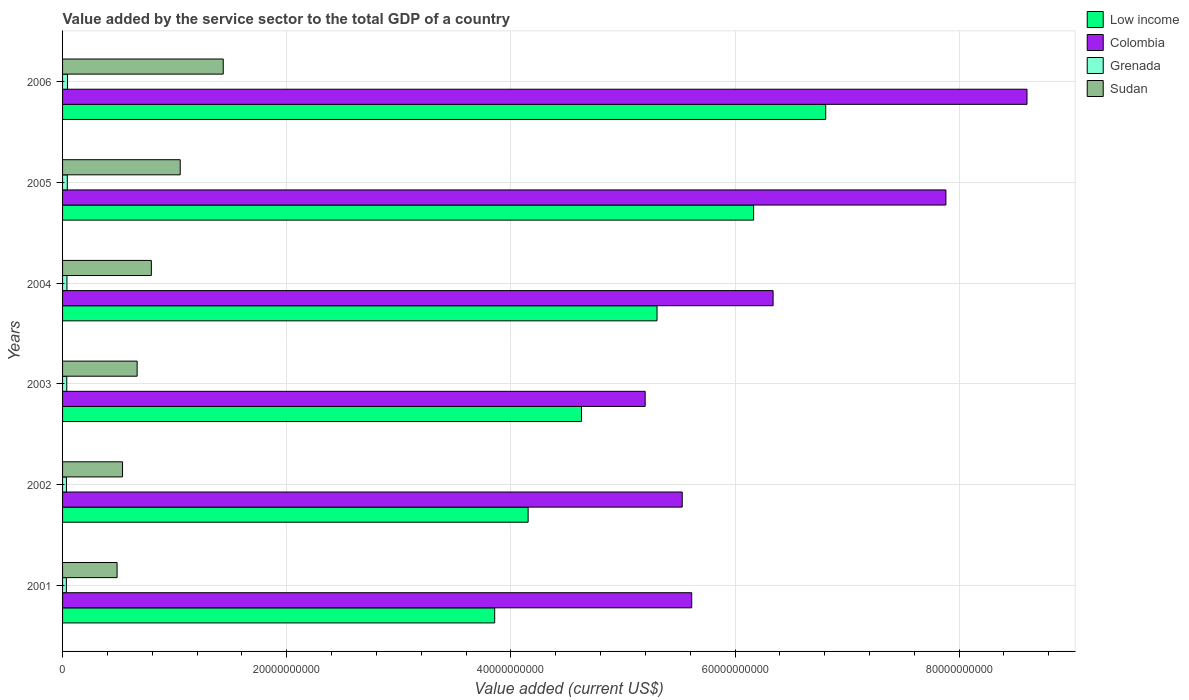Are the number of bars per tick equal to the number of legend labels?
Provide a succinct answer. Yes. How many bars are there on the 3rd tick from the top?
Provide a short and direct response. 4. How many bars are there on the 3rd tick from the bottom?
Offer a terse response. 4. What is the value added by the service sector to the total GDP in Colombia in 2004?
Provide a succinct answer. 6.34e+1. Across all years, what is the maximum value added by the service sector to the total GDP in Low income?
Your answer should be very brief. 6.81e+1. Across all years, what is the minimum value added by the service sector to the total GDP in Low income?
Ensure brevity in your answer.  3.86e+1. What is the total value added by the service sector to the total GDP in Sudan in the graph?
Ensure brevity in your answer.  4.96e+1. What is the difference between the value added by the service sector to the total GDP in Sudan in 2002 and that in 2005?
Your response must be concise. -5.15e+09. What is the difference between the value added by the service sector to the total GDP in Grenada in 2001 and the value added by the service sector to the total GDP in Low income in 2003?
Your response must be concise. -4.60e+1. What is the average value added by the service sector to the total GDP in Low income per year?
Keep it short and to the point. 5.15e+1. In the year 2004, what is the difference between the value added by the service sector to the total GDP in Grenada and value added by the service sector to the total GDP in Colombia?
Provide a short and direct response. -6.30e+1. In how many years, is the value added by the service sector to the total GDP in Low income greater than 44000000000 US$?
Offer a terse response. 4. What is the ratio of the value added by the service sector to the total GDP in Low income in 2002 to that in 2003?
Ensure brevity in your answer.  0.9. Is the difference between the value added by the service sector to the total GDP in Grenada in 2001 and 2002 greater than the difference between the value added by the service sector to the total GDP in Colombia in 2001 and 2002?
Provide a succinct answer. No. What is the difference between the highest and the second highest value added by the service sector to the total GDP in Grenada?
Ensure brevity in your answer.  1.71e+07. What is the difference between the highest and the lowest value added by the service sector to the total GDP in Sudan?
Your response must be concise. 9.47e+09. Is the sum of the value added by the service sector to the total GDP in Low income in 2003 and 2004 greater than the maximum value added by the service sector to the total GDP in Sudan across all years?
Ensure brevity in your answer.  Yes. What does the 1st bar from the top in 2003 represents?
Your answer should be very brief. Sudan. What does the 2nd bar from the bottom in 2004 represents?
Make the answer very short. Colombia. Is it the case that in every year, the sum of the value added by the service sector to the total GDP in Sudan and value added by the service sector to the total GDP in Low income is greater than the value added by the service sector to the total GDP in Grenada?
Give a very brief answer. Yes. Are the values on the major ticks of X-axis written in scientific E-notation?
Provide a short and direct response. No. Does the graph contain any zero values?
Your answer should be compact. No. Does the graph contain grids?
Ensure brevity in your answer.  Yes. Where does the legend appear in the graph?
Your response must be concise. Top right. How are the legend labels stacked?
Offer a very short reply. Vertical. What is the title of the graph?
Give a very brief answer. Value added by the service sector to the total GDP of a country. Does "Bolivia" appear as one of the legend labels in the graph?
Keep it short and to the point. No. What is the label or title of the X-axis?
Keep it short and to the point. Value added (current US$). What is the label or title of the Y-axis?
Give a very brief answer. Years. What is the Value added (current US$) in Low income in 2001?
Keep it short and to the point. 3.86e+1. What is the Value added (current US$) in Colombia in 2001?
Offer a terse response. 5.61e+1. What is the Value added (current US$) in Grenada in 2001?
Make the answer very short. 3.39e+08. What is the Value added (current US$) in Sudan in 2001?
Ensure brevity in your answer.  4.87e+09. What is the Value added (current US$) in Low income in 2002?
Give a very brief answer. 4.15e+1. What is the Value added (current US$) in Colombia in 2002?
Keep it short and to the point. 5.53e+1. What is the Value added (current US$) in Grenada in 2002?
Ensure brevity in your answer.  3.46e+08. What is the Value added (current US$) in Sudan in 2002?
Offer a terse response. 5.35e+09. What is the Value added (current US$) of Low income in 2003?
Keep it short and to the point. 4.63e+1. What is the Value added (current US$) of Colombia in 2003?
Offer a very short reply. 5.20e+1. What is the Value added (current US$) in Grenada in 2003?
Your response must be concise. 3.75e+08. What is the Value added (current US$) of Sudan in 2003?
Provide a short and direct response. 6.65e+09. What is the Value added (current US$) in Low income in 2004?
Offer a very short reply. 5.30e+1. What is the Value added (current US$) of Colombia in 2004?
Your response must be concise. 6.34e+1. What is the Value added (current US$) of Grenada in 2004?
Keep it short and to the point. 3.91e+08. What is the Value added (current US$) in Sudan in 2004?
Make the answer very short. 7.92e+09. What is the Value added (current US$) of Low income in 2005?
Provide a short and direct response. 6.17e+1. What is the Value added (current US$) of Colombia in 2005?
Offer a very short reply. 7.88e+1. What is the Value added (current US$) of Grenada in 2005?
Offer a very short reply. 4.21e+08. What is the Value added (current US$) of Sudan in 2005?
Provide a short and direct response. 1.05e+1. What is the Value added (current US$) of Low income in 2006?
Make the answer very short. 6.81e+1. What is the Value added (current US$) of Colombia in 2006?
Give a very brief answer. 8.61e+1. What is the Value added (current US$) of Grenada in 2006?
Ensure brevity in your answer.  4.38e+08. What is the Value added (current US$) of Sudan in 2006?
Provide a succinct answer. 1.43e+1. Across all years, what is the maximum Value added (current US$) in Low income?
Offer a very short reply. 6.81e+1. Across all years, what is the maximum Value added (current US$) in Colombia?
Keep it short and to the point. 8.61e+1. Across all years, what is the maximum Value added (current US$) in Grenada?
Ensure brevity in your answer.  4.38e+08. Across all years, what is the maximum Value added (current US$) in Sudan?
Ensure brevity in your answer.  1.43e+1. Across all years, what is the minimum Value added (current US$) in Low income?
Give a very brief answer. 3.86e+1. Across all years, what is the minimum Value added (current US$) in Colombia?
Give a very brief answer. 5.20e+1. Across all years, what is the minimum Value added (current US$) of Grenada?
Your response must be concise. 3.39e+08. Across all years, what is the minimum Value added (current US$) of Sudan?
Make the answer very short. 4.87e+09. What is the total Value added (current US$) of Low income in the graph?
Offer a very short reply. 3.09e+11. What is the total Value added (current US$) of Colombia in the graph?
Give a very brief answer. 3.92e+11. What is the total Value added (current US$) of Grenada in the graph?
Your answer should be very brief. 2.31e+09. What is the total Value added (current US$) in Sudan in the graph?
Offer a terse response. 4.96e+1. What is the difference between the Value added (current US$) of Low income in 2001 and that in 2002?
Provide a succinct answer. -2.98e+09. What is the difference between the Value added (current US$) of Colombia in 2001 and that in 2002?
Ensure brevity in your answer.  8.46e+08. What is the difference between the Value added (current US$) of Grenada in 2001 and that in 2002?
Offer a very short reply. -6.88e+06. What is the difference between the Value added (current US$) of Sudan in 2001 and that in 2002?
Keep it short and to the point. -4.85e+08. What is the difference between the Value added (current US$) in Low income in 2001 and that in 2003?
Your answer should be compact. -7.75e+09. What is the difference between the Value added (current US$) in Colombia in 2001 and that in 2003?
Your answer should be very brief. 4.15e+09. What is the difference between the Value added (current US$) of Grenada in 2001 and that in 2003?
Your response must be concise. -3.52e+07. What is the difference between the Value added (current US$) in Sudan in 2001 and that in 2003?
Offer a very short reply. -1.79e+09. What is the difference between the Value added (current US$) in Low income in 2001 and that in 2004?
Your response must be concise. -1.45e+1. What is the difference between the Value added (current US$) of Colombia in 2001 and that in 2004?
Provide a short and direct response. -7.26e+09. What is the difference between the Value added (current US$) of Grenada in 2001 and that in 2004?
Keep it short and to the point. -5.12e+07. What is the difference between the Value added (current US$) in Sudan in 2001 and that in 2004?
Provide a succinct answer. -3.06e+09. What is the difference between the Value added (current US$) of Low income in 2001 and that in 2005?
Your answer should be very brief. -2.31e+1. What is the difference between the Value added (current US$) of Colombia in 2001 and that in 2005?
Provide a succinct answer. -2.27e+1. What is the difference between the Value added (current US$) of Grenada in 2001 and that in 2005?
Keep it short and to the point. -8.13e+07. What is the difference between the Value added (current US$) of Sudan in 2001 and that in 2005?
Ensure brevity in your answer.  -5.63e+09. What is the difference between the Value added (current US$) in Low income in 2001 and that in 2006?
Provide a succinct answer. -2.95e+1. What is the difference between the Value added (current US$) of Colombia in 2001 and that in 2006?
Ensure brevity in your answer.  -2.99e+1. What is the difference between the Value added (current US$) in Grenada in 2001 and that in 2006?
Your answer should be compact. -9.84e+07. What is the difference between the Value added (current US$) of Sudan in 2001 and that in 2006?
Your answer should be compact. -9.47e+09. What is the difference between the Value added (current US$) of Low income in 2002 and that in 2003?
Your answer should be compact. -4.76e+09. What is the difference between the Value added (current US$) of Colombia in 2002 and that in 2003?
Make the answer very short. 3.31e+09. What is the difference between the Value added (current US$) in Grenada in 2002 and that in 2003?
Offer a terse response. -2.84e+07. What is the difference between the Value added (current US$) of Sudan in 2002 and that in 2003?
Keep it short and to the point. -1.30e+09. What is the difference between the Value added (current US$) of Low income in 2002 and that in 2004?
Provide a succinct answer. -1.15e+1. What is the difference between the Value added (current US$) in Colombia in 2002 and that in 2004?
Keep it short and to the point. -8.11e+09. What is the difference between the Value added (current US$) in Grenada in 2002 and that in 2004?
Provide a succinct answer. -4.44e+07. What is the difference between the Value added (current US$) in Sudan in 2002 and that in 2004?
Give a very brief answer. -2.57e+09. What is the difference between the Value added (current US$) of Low income in 2002 and that in 2005?
Ensure brevity in your answer.  -2.01e+1. What is the difference between the Value added (current US$) of Colombia in 2002 and that in 2005?
Your answer should be compact. -2.35e+1. What is the difference between the Value added (current US$) in Grenada in 2002 and that in 2005?
Provide a succinct answer. -7.45e+07. What is the difference between the Value added (current US$) of Sudan in 2002 and that in 2005?
Keep it short and to the point. -5.15e+09. What is the difference between the Value added (current US$) of Low income in 2002 and that in 2006?
Offer a terse response. -2.66e+1. What is the difference between the Value added (current US$) in Colombia in 2002 and that in 2006?
Give a very brief answer. -3.08e+1. What is the difference between the Value added (current US$) of Grenada in 2002 and that in 2006?
Provide a short and direct response. -9.15e+07. What is the difference between the Value added (current US$) of Sudan in 2002 and that in 2006?
Offer a very short reply. -8.99e+09. What is the difference between the Value added (current US$) in Low income in 2003 and that in 2004?
Offer a terse response. -6.74e+09. What is the difference between the Value added (current US$) of Colombia in 2003 and that in 2004?
Provide a short and direct response. -1.14e+1. What is the difference between the Value added (current US$) in Grenada in 2003 and that in 2004?
Offer a very short reply. -1.60e+07. What is the difference between the Value added (current US$) of Sudan in 2003 and that in 2004?
Keep it short and to the point. -1.27e+09. What is the difference between the Value added (current US$) of Low income in 2003 and that in 2005?
Provide a short and direct response. -1.54e+1. What is the difference between the Value added (current US$) of Colombia in 2003 and that in 2005?
Your response must be concise. -2.68e+1. What is the difference between the Value added (current US$) of Grenada in 2003 and that in 2005?
Offer a very short reply. -4.61e+07. What is the difference between the Value added (current US$) in Sudan in 2003 and that in 2005?
Ensure brevity in your answer.  -3.84e+09. What is the difference between the Value added (current US$) in Low income in 2003 and that in 2006?
Offer a very short reply. -2.18e+1. What is the difference between the Value added (current US$) in Colombia in 2003 and that in 2006?
Make the answer very short. -3.41e+1. What is the difference between the Value added (current US$) in Grenada in 2003 and that in 2006?
Provide a short and direct response. -6.32e+07. What is the difference between the Value added (current US$) of Sudan in 2003 and that in 2006?
Your answer should be very brief. -7.68e+09. What is the difference between the Value added (current US$) in Low income in 2004 and that in 2005?
Ensure brevity in your answer.  -8.62e+09. What is the difference between the Value added (current US$) of Colombia in 2004 and that in 2005?
Provide a short and direct response. -1.54e+1. What is the difference between the Value added (current US$) in Grenada in 2004 and that in 2005?
Provide a short and direct response. -3.01e+07. What is the difference between the Value added (current US$) of Sudan in 2004 and that in 2005?
Offer a terse response. -2.58e+09. What is the difference between the Value added (current US$) of Low income in 2004 and that in 2006?
Keep it short and to the point. -1.51e+1. What is the difference between the Value added (current US$) of Colombia in 2004 and that in 2006?
Provide a succinct answer. -2.27e+1. What is the difference between the Value added (current US$) in Grenada in 2004 and that in 2006?
Provide a succinct answer. -4.72e+07. What is the difference between the Value added (current US$) of Sudan in 2004 and that in 2006?
Your answer should be very brief. -6.42e+09. What is the difference between the Value added (current US$) in Low income in 2005 and that in 2006?
Ensure brevity in your answer.  -6.43e+09. What is the difference between the Value added (current US$) of Colombia in 2005 and that in 2006?
Offer a very short reply. -7.23e+09. What is the difference between the Value added (current US$) in Grenada in 2005 and that in 2006?
Ensure brevity in your answer.  -1.71e+07. What is the difference between the Value added (current US$) in Sudan in 2005 and that in 2006?
Your answer should be compact. -3.84e+09. What is the difference between the Value added (current US$) in Low income in 2001 and the Value added (current US$) in Colombia in 2002?
Your response must be concise. -1.67e+1. What is the difference between the Value added (current US$) in Low income in 2001 and the Value added (current US$) in Grenada in 2002?
Provide a short and direct response. 3.82e+1. What is the difference between the Value added (current US$) in Low income in 2001 and the Value added (current US$) in Sudan in 2002?
Offer a very short reply. 3.32e+1. What is the difference between the Value added (current US$) in Colombia in 2001 and the Value added (current US$) in Grenada in 2002?
Offer a terse response. 5.58e+1. What is the difference between the Value added (current US$) of Colombia in 2001 and the Value added (current US$) of Sudan in 2002?
Keep it short and to the point. 5.08e+1. What is the difference between the Value added (current US$) of Grenada in 2001 and the Value added (current US$) of Sudan in 2002?
Keep it short and to the point. -5.01e+09. What is the difference between the Value added (current US$) of Low income in 2001 and the Value added (current US$) of Colombia in 2003?
Ensure brevity in your answer.  -1.34e+1. What is the difference between the Value added (current US$) in Low income in 2001 and the Value added (current US$) in Grenada in 2003?
Provide a short and direct response. 3.82e+1. What is the difference between the Value added (current US$) in Low income in 2001 and the Value added (current US$) in Sudan in 2003?
Make the answer very short. 3.19e+1. What is the difference between the Value added (current US$) in Colombia in 2001 and the Value added (current US$) in Grenada in 2003?
Offer a very short reply. 5.58e+1. What is the difference between the Value added (current US$) of Colombia in 2001 and the Value added (current US$) of Sudan in 2003?
Provide a succinct answer. 4.95e+1. What is the difference between the Value added (current US$) of Grenada in 2001 and the Value added (current US$) of Sudan in 2003?
Offer a terse response. -6.31e+09. What is the difference between the Value added (current US$) in Low income in 2001 and the Value added (current US$) in Colombia in 2004?
Provide a succinct answer. -2.48e+1. What is the difference between the Value added (current US$) in Low income in 2001 and the Value added (current US$) in Grenada in 2004?
Keep it short and to the point. 3.82e+1. What is the difference between the Value added (current US$) in Low income in 2001 and the Value added (current US$) in Sudan in 2004?
Provide a succinct answer. 3.06e+1. What is the difference between the Value added (current US$) in Colombia in 2001 and the Value added (current US$) in Grenada in 2004?
Give a very brief answer. 5.57e+1. What is the difference between the Value added (current US$) in Colombia in 2001 and the Value added (current US$) in Sudan in 2004?
Provide a succinct answer. 4.82e+1. What is the difference between the Value added (current US$) in Grenada in 2001 and the Value added (current US$) in Sudan in 2004?
Your response must be concise. -7.58e+09. What is the difference between the Value added (current US$) in Low income in 2001 and the Value added (current US$) in Colombia in 2005?
Offer a terse response. -4.03e+1. What is the difference between the Value added (current US$) in Low income in 2001 and the Value added (current US$) in Grenada in 2005?
Your answer should be compact. 3.81e+1. What is the difference between the Value added (current US$) of Low income in 2001 and the Value added (current US$) of Sudan in 2005?
Ensure brevity in your answer.  2.81e+1. What is the difference between the Value added (current US$) of Colombia in 2001 and the Value added (current US$) of Grenada in 2005?
Your answer should be compact. 5.57e+1. What is the difference between the Value added (current US$) in Colombia in 2001 and the Value added (current US$) in Sudan in 2005?
Keep it short and to the point. 4.56e+1. What is the difference between the Value added (current US$) in Grenada in 2001 and the Value added (current US$) in Sudan in 2005?
Ensure brevity in your answer.  -1.02e+1. What is the difference between the Value added (current US$) in Low income in 2001 and the Value added (current US$) in Colombia in 2006?
Give a very brief answer. -4.75e+1. What is the difference between the Value added (current US$) in Low income in 2001 and the Value added (current US$) in Grenada in 2006?
Provide a short and direct response. 3.81e+1. What is the difference between the Value added (current US$) in Low income in 2001 and the Value added (current US$) in Sudan in 2006?
Keep it short and to the point. 2.42e+1. What is the difference between the Value added (current US$) of Colombia in 2001 and the Value added (current US$) of Grenada in 2006?
Offer a terse response. 5.57e+1. What is the difference between the Value added (current US$) of Colombia in 2001 and the Value added (current US$) of Sudan in 2006?
Ensure brevity in your answer.  4.18e+1. What is the difference between the Value added (current US$) of Grenada in 2001 and the Value added (current US$) of Sudan in 2006?
Provide a succinct answer. -1.40e+1. What is the difference between the Value added (current US$) in Low income in 2002 and the Value added (current US$) in Colombia in 2003?
Offer a terse response. -1.04e+1. What is the difference between the Value added (current US$) in Low income in 2002 and the Value added (current US$) in Grenada in 2003?
Make the answer very short. 4.12e+1. What is the difference between the Value added (current US$) in Low income in 2002 and the Value added (current US$) in Sudan in 2003?
Provide a short and direct response. 3.49e+1. What is the difference between the Value added (current US$) in Colombia in 2002 and the Value added (current US$) in Grenada in 2003?
Your answer should be very brief. 5.49e+1. What is the difference between the Value added (current US$) of Colombia in 2002 and the Value added (current US$) of Sudan in 2003?
Offer a terse response. 4.86e+1. What is the difference between the Value added (current US$) in Grenada in 2002 and the Value added (current US$) in Sudan in 2003?
Keep it short and to the point. -6.31e+09. What is the difference between the Value added (current US$) of Low income in 2002 and the Value added (current US$) of Colombia in 2004?
Keep it short and to the point. -2.19e+1. What is the difference between the Value added (current US$) in Low income in 2002 and the Value added (current US$) in Grenada in 2004?
Provide a succinct answer. 4.12e+1. What is the difference between the Value added (current US$) of Low income in 2002 and the Value added (current US$) of Sudan in 2004?
Your answer should be compact. 3.36e+1. What is the difference between the Value added (current US$) of Colombia in 2002 and the Value added (current US$) of Grenada in 2004?
Make the answer very short. 5.49e+1. What is the difference between the Value added (current US$) in Colombia in 2002 and the Value added (current US$) in Sudan in 2004?
Your response must be concise. 4.74e+1. What is the difference between the Value added (current US$) of Grenada in 2002 and the Value added (current US$) of Sudan in 2004?
Your response must be concise. -7.58e+09. What is the difference between the Value added (current US$) of Low income in 2002 and the Value added (current US$) of Colombia in 2005?
Give a very brief answer. -3.73e+1. What is the difference between the Value added (current US$) of Low income in 2002 and the Value added (current US$) of Grenada in 2005?
Give a very brief answer. 4.11e+1. What is the difference between the Value added (current US$) in Low income in 2002 and the Value added (current US$) in Sudan in 2005?
Ensure brevity in your answer.  3.10e+1. What is the difference between the Value added (current US$) of Colombia in 2002 and the Value added (current US$) of Grenada in 2005?
Keep it short and to the point. 5.49e+1. What is the difference between the Value added (current US$) of Colombia in 2002 and the Value added (current US$) of Sudan in 2005?
Give a very brief answer. 4.48e+1. What is the difference between the Value added (current US$) of Grenada in 2002 and the Value added (current US$) of Sudan in 2005?
Your answer should be very brief. -1.02e+1. What is the difference between the Value added (current US$) of Low income in 2002 and the Value added (current US$) of Colombia in 2006?
Give a very brief answer. -4.45e+1. What is the difference between the Value added (current US$) of Low income in 2002 and the Value added (current US$) of Grenada in 2006?
Provide a short and direct response. 4.11e+1. What is the difference between the Value added (current US$) of Low income in 2002 and the Value added (current US$) of Sudan in 2006?
Your answer should be very brief. 2.72e+1. What is the difference between the Value added (current US$) of Colombia in 2002 and the Value added (current US$) of Grenada in 2006?
Your answer should be compact. 5.49e+1. What is the difference between the Value added (current US$) of Colombia in 2002 and the Value added (current US$) of Sudan in 2006?
Keep it short and to the point. 4.10e+1. What is the difference between the Value added (current US$) in Grenada in 2002 and the Value added (current US$) in Sudan in 2006?
Provide a succinct answer. -1.40e+1. What is the difference between the Value added (current US$) of Low income in 2003 and the Value added (current US$) of Colombia in 2004?
Ensure brevity in your answer.  -1.71e+1. What is the difference between the Value added (current US$) of Low income in 2003 and the Value added (current US$) of Grenada in 2004?
Your answer should be compact. 4.59e+1. What is the difference between the Value added (current US$) of Low income in 2003 and the Value added (current US$) of Sudan in 2004?
Offer a terse response. 3.84e+1. What is the difference between the Value added (current US$) in Colombia in 2003 and the Value added (current US$) in Grenada in 2004?
Your answer should be compact. 5.16e+1. What is the difference between the Value added (current US$) in Colombia in 2003 and the Value added (current US$) in Sudan in 2004?
Offer a terse response. 4.41e+1. What is the difference between the Value added (current US$) of Grenada in 2003 and the Value added (current US$) of Sudan in 2004?
Provide a short and direct response. -7.55e+09. What is the difference between the Value added (current US$) of Low income in 2003 and the Value added (current US$) of Colombia in 2005?
Keep it short and to the point. -3.25e+1. What is the difference between the Value added (current US$) of Low income in 2003 and the Value added (current US$) of Grenada in 2005?
Keep it short and to the point. 4.59e+1. What is the difference between the Value added (current US$) of Low income in 2003 and the Value added (current US$) of Sudan in 2005?
Your answer should be compact. 3.58e+1. What is the difference between the Value added (current US$) of Colombia in 2003 and the Value added (current US$) of Grenada in 2005?
Give a very brief answer. 5.16e+1. What is the difference between the Value added (current US$) in Colombia in 2003 and the Value added (current US$) in Sudan in 2005?
Your answer should be very brief. 4.15e+1. What is the difference between the Value added (current US$) of Grenada in 2003 and the Value added (current US$) of Sudan in 2005?
Offer a very short reply. -1.01e+1. What is the difference between the Value added (current US$) of Low income in 2003 and the Value added (current US$) of Colombia in 2006?
Your response must be concise. -3.98e+1. What is the difference between the Value added (current US$) in Low income in 2003 and the Value added (current US$) in Grenada in 2006?
Your answer should be very brief. 4.59e+1. What is the difference between the Value added (current US$) of Low income in 2003 and the Value added (current US$) of Sudan in 2006?
Provide a succinct answer. 3.20e+1. What is the difference between the Value added (current US$) of Colombia in 2003 and the Value added (current US$) of Grenada in 2006?
Your answer should be compact. 5.15e+1. What is the difference between the Value added (current US$) in Colombia in 2003 and the Value added (current US$) in Sudan in 2006?
Offer a very short reply. 3.76e+1. What is the difference between the Value added (current US$) in Grenada in 2003 and the Value added (current US$) in Sudan in 2006?
Make the answer very short. -1.40e+1. What is the difference between the Value added (current US$) of Low income in 2004 and the Value added (current US$) of Colombia in 2005?
Your response must be concise. -2.58e+1. What is the difference between the Value added (current US$) in Low income in 2004 and the Value added (current US$) in Grenada in 2005?
Provide a short and direct response. 5.26e+1. What is the difference between the Value added (current US$) in Low income in 2004 and the Value added (current US$) in Sudan in 2005?
Provide a succinct answer. 4.25e+1. What is the difference between the Value added (current US$) of Colombia in 2004 and the Value added (current US$) of Grenada in 2005?
Your response must be concise. 6.30e+1. What is the difference between the Value added (current US$) of Colombia in 2004 and the Value added (current US$) of Sudan in 2005?
Your response must be concise. 5.29e+1. What is the difference between the Value added (current US$) in Grenada in 2004 and the Value added (current US$) in Sudan in 2005?
Provide a short and direct response. -1.01e+1. What is the difference between the Value added (current US$) of Low income in 2004 and the Value added (current US$) of Colombia in 2006?
Your answer should be compact. -3.30e+1. What is the difference between the Value added (current US$) of Low income in 2004 and the Value added (current US$) of Grenada in 2006?
Make the answer very short. 5.26e+1. What is the difference between the Value added (current US$) of Low income in 2004 and the Value added (current US$) of Sudan in 2006?
Make the answer very short. 3.87e+1. What is the difference between the Value added (current US$) of Colombia in 2004 and the Value added (current US$) of Grenada in 2006?
Your answer should be compact. 6.30e+1. What is the difference between the Value added (current US$) in Colombia in 2004 and the Value added (current US$) in Sudan in 2006?
Offer a very short reply. 4.91e+1. What is the difference between the Value added (current US$) of Grenada in 2004 and the Value added (current US$) of Sudan in 2006?
Offer a very short reply. -1.39e+1. What is the difference between the Value added (current US$) in Low income in 2005 and the Value added (current US$) in Colombia in 2006?
Keep it short and to the point. -2.44e+1. What is the difference between the Value added (current US$) in Low income in 2005 and the Value added (current US$) in Grenada in 2006?
Offer a terse response. 6.12e+1. What is the difference between the Value added (current US$) of Low income in 2005 and the Value added (current US$) of Sudan in 2006?
Keep it short and to the point. 4.73e+1. What is the difference between the Value added (current US$) in Colombia in 2005 and the Value added (current US$) in Grenada in 2006?
Your answer should be very brief. 7.84e+1. What is the difference between the Value added (current US$) of Colombia in 2005 and the Value added (current US$) of Sudan in 2006?
Give a very brief answer. 6.45e+1. What is the difference between the Value added (current US$) in Grenada in 2005 and the Value added (current US$) in Sudan in 2006?
Offer a very short reply. -1.39e+1. What is the average Value added (current US$) of Low income per year?
Your answer should be very brief. 5.15e+1. What is the average Value added (current US$) in Colombia per year?
Ensure brevity in your answer.  6.53e+1. What is the average Value added (current US$) in Grenada per year?
Provide a short and direct response. 3.85e+08. What is the average Value added (current US$) in Sudan per year?
Keep it short and to the point. 8.27e+09. In the year 2001, what is the difference between the Value added (current US$) of Low income and Value added (current US$) of Colombia?
Provide a succinct answer. -1.76e+1. In the year 2001, what is the difference between the Value added (current US$) of Low income and Value added (current US$) of Grenada?
Offer a terse response. 3.82e+1. In the year 2001, what is the difference between the Value added (current US$) of Low income and Value added (current US$) of Sudan?
Offer a terse response. 3.37e+1. In the year 2001, what is the difference between the Value added (current US$) in Colombia and Value added (current US$) in Grenada?
Keep it short and to the point. 5.58e+1. In the year 2001, what is the difference between the Value added (current US$) in Colombia and Value added (current US$) in Sudan?
Provide a short and direct response. 5.13e+1. In the year 2001, what is the difference between the Value added (current US$) of Grenada and Value added (current US$) of Sudan?
Give a very brief answer. -4.53e+09. In the year 2002, what is the difference between the Value added (current US$) in Low income and Value added (current US$) in Colombia?
Your answer should be very brief. -1.38e+1. In the year 2002, what is the difference between the Value added (current US$) in Low income and Value added (current US$) in Grenada?
Keep it short and to the point. 4.12e+1. In the year 2002, what is the difference between the Value added (current US$) of Low income and Value added (current US$) of Sudan?
Provide a succinct answer. 3.62e+1. In the year 2002, what is the difference between the Value added (current US$) of Colombia and Value added (current US$) of Grenada?
Your answer should be compact. 5.49e+1. In the year 2002, what is the difference between the Value added (current US$) in Colombia and Value added (current US$) in Sudan?
Make the answer very short. 4.99e+1. In the year 2002, what is the difference between the Value added (current US$) of Grenada and Value added (current US$) of Sudan?
Ensure brevity in your answer.  -5.00e+09. In the year 2003, what is the difference between the Value added (current US$) of Low income and Value added (current US$) of Colombia?
Offer a very short reply. -5.68e+09. In the year 2003, what is the difference between the Value added (current US$) of Low income and Value added (current US$) of Grenada?
Give a very brief answer. 4.59e+1. In the year 2003, what is the difference between the Value added (current US$) of Low income and Value added (current US$) of Sudan?
Make the answer very short. 3.96e+1. In the year 2003, what is the difference between the Value added (current US$) of Colombia and Value added (current US$) of Grenada?
Offer a terse response. 5.16e+1. In the year 2003, what is the difference between the Value added (current US$) of Colombia and Value added (current US$) of Sudan?
Your response must be concise. 4.53e+1. In the year 2003, what is the difference between the Value added (current US$) in Grenada and Value added (current US$) in Sudan?
Offer a terse response. -6.28e+09. In the year 2004, what is the difference between the Value added (current US$) of Low income and Value added (current US$) of Colombia?
Provide a short and direct response. -1.04e+1. In the year 2004, what is the difference between the Value added (current US$) in Low income and Value added (current US$) in Grenada?
Your answer should be compact. 5.27e+1. In the year 2004, what is the difference between the Value added (current US$) of Low income and Value added (current US$) of Sudan?
Your response must be concise. 4.51e+1. In the year 2004, what is the difference between the Value added (current US$) in Colombia and Value added (current US$) in Grenada?
Your answer should be very brief. 6.30e+1. In the year 2004, what is the difference between the Value added (current US$) in Colombia and Value added (current US$) in Sudan?
Make the answer very short. 5.55e+1. In the year 2004, what is the difference between the Value added (current US$) in Grenada and Value added (current US$) in Sudan?
Provide a short and direct response. -7.53e+09. In the year 2005, what is the difference between the Value added (current US$) of Low income and Value added (current US$) of Colombia?
Provide a short and direct response. -1.72e+1. In the year 2005, what is the difference between the Value added (current US$) in Low income and Value added (current US$) in Grenada?
Your answer should be very brief. 6.12e+1. In the year 2005, what is the difference between the Value added (current US$) in Low income and Value added (current US$) in Sudan?
Provide a short and direct response. 5.12e+1. In the year 2005, what is the difference between the Value added (current US$) in Colombia and Value added (current US$) in Grenada?
Keep it short and to the point. 7.84e+1. In the year 2005, what is the difference between the Value added (current US$) in Colombia and Value added (current US$) in Sudan?
Provide a succinct answer. 6.83e+1. In the year 2005, what is the difference between the Value added (current US$) in Grenada and Value added (current US$) in Sudan?
Offer a terse response. -1.01e+1. In the year 2006, what is the difference between the Value added (current US$) in Low income and Value added (current US$) in Colombia?
Make the answer very short. -1.80e+1. In the year 2006, what is the difference between the Value added (current US$) of Low income and Value added (current US$) of Grenada?
Give a very brief answer. 6.77e+1. In the year 2006, what is the difference between the Value added (current US$) in Low income and Value added (current US$) in Sudan?
Keep it short and to the point. 5.38e+1. In the year 2006, what is the difference between the Value added (current US$) of Colombia and Value added (current US$) of Grenada?
Your answer should be compact. 8.56e+1. In the year 2006, what is the difference between the Value added (current US$) of Colombia and Value added (current US$) of Sudan?
Give a very brief answer. 7.17e+1. In the year 2006, what is the difference between the Value added (current US$) in Grenada and Value added (current US$) in Sudan?
Keep it short and to the point. -1.39e+1. What is the ratio of the Value added (current US$) in Low income in 2001 to that in 2002?
Your answer should be very brief. 0.93. What is the ratio of the Value added (current US$) in Colombia in 2001 to that in 2002?
Give a very brief answer. 1.02. What is the ratio of the Value added (current US$) of Grenada in 2001 to that in 2002?
Offer a terse response. 0.98. What is the ratio of the Value added (current US$) of Sudan in 2001 to that in 2002?
Ensure brevity in your answer.  0.91. What is the ratio of the Value added (current US$) of Low income in 2001 to that in 2003?
Your response must be concise. 0.83. What is the ratio of the Value added (current US$) in Colombia in 2001 to that in 2003?
Offer a terse response. 1.08. What is the ratio of the Value added (current US$) of Grenada in 2001 to that in 2003?
Offer a terse response. 0.91. What is the ratio of the Value added (current US$) in Sudan in 2001 to that in 2003?
Offer a very short reply. 0.73. What is the ratio of the Value added (current US$) in Low income in 2001 to that in 2004?
Give a very brief answer. 0.73. What is the ratio of the Value added (current US$) in Colombia in 2001 to that in 2004?
Make the answer very short. 0.89. What is the ratio of the Value added (current US$) in Grenada in 2001 to that in 2004?
Offer a terse response. 0.87. What is the ratio of the Value added (current US$) in Sudan in 2001 to that in 2004?
Offer a terse response. 0.61. What is the ratio of the Value added (current US$) of Low income in 2001 to that in 2005?
Make the answer very short. 0.63. What is the ratio of the Value added (current US$) of Colombia in 2001 to that in 2005?
Your answer should be compact. 0.71. What is the ratio of the Value added (current US$) of Grenada in 2001 to that in 2005?
Offer a terse response. 0.81. What is the ratio of the Value added (current US$) of Sudan in 2001 to that in 2005?
Make the answer very short. 0.46. What is the ratio of the Value added (current US$) in Low income in 2001 to that in 2006?
Your answer should be compact. 0.57. What is the ratio of the Value added (current US$) in Colombia in 2001 to that in 2006?
Give a very brief answer. 0.65. What is the ratio of the Value added (current US$) in Grenada in 2001 to that in 2006?
Offer a very short reply. 0.78. What is the ratio of the Value added (current US$) of Sudan in 2001 to that in 2006?
Ensure brevity in your answer.  0.34. What is the ratio of the Value added (current US$) in Low income in 2002 to that in 2003?
Your answer should be compact. 0.9. What is the ratio of the Value added (current US$) in Colombia in 2002 to that in 2003?
Your answer should be very brief. 1.06. What is the ratio of the Value added (current US$) of Grenada in 2002 to that in 2003?
Offer a terse response. 0.92. What is the ratio of the Value added (current US$) in Sudan in 2002 to that in 2003?
Ensure brevity in your answer.  0.8. What is the ratio of the Value added (current US$) in Low income in 2002 to that in 2004?
Provide a succinct answer. 0.78. What is the ratio of the Value added (current US$) of Colombia in 2002 to that in 2004?
Provide a succinct answer. 0.87. What is the ratio of the Value added (current US$) in Grenada in 2002 to that in 2004?
Give a very brief answer. 0.89. What is the ratio of the Value added (current US$) of Sudan in 2002 to that in 2004?
Your answer should be very brief. 0.68. What is the ratio of the Value added (current US$) of Low income in 2002 to that in 2005?
Provide a succinct answer. 0.67. What is the ratio of the Value added (current US$) of Colombia in 2002 to that in 2005?
Offer a very short reply. 0.7. What is the ratio of the Value added (current US$) of Grenada in 2002 to that in 2005?
Give a very brief answer. 0.82. What is the ratio of the Value added (current US$) in Sudan in 2002 to that in 2005?
Keep it short and to the point. 0.51. What is the ratio of the Value added (current US$) in Low income in 2002 to that in 2006?
Ensure brevity in your answer.  0.61. What is the ratio of the Value added (current US$) of Colombia in 2002 to that in 2006?
Provide a short and direct response. 0.64. What is the ratio of the Value added (current US$) in Grenada in 2002 to that in 2006?
Offer a very short reply. 0.79. What is the ratio of the Value added (current US$) in Sudan in 2002 to that in 2006?
Your response must be concise. 0.37. What is the ratio of the Value added (current US$) in Low income in 2003 to that in 2004?
Provide a succinct answer. 0.87. What is the ratio of the Value added (current US$) of Colombia in 2003 to that in 2004?
Offer a terse response. 0.82. What is the ratio of the Value added (current US$) in Sudan in 2003 to that in 2004?
Provide a short and direct response. 0.84. What is the ratio of the Value added (current US$) in Low income in 2003 to that in 2005?
Give a very brief answer. 0.75. What is the ratio of the Value added (current US$) in Colombia in 2003 to that in 2005?
Your answer should be compact. 0.66. What is the ratio of the Value added (current US$) in Grenada in 2003 to that in 2005?
Provide a short and direct response. 0.89. What is the ratio of the Value added (current US$) of Sudan in 2003 to that in 2005?
Your answer should be very brief. 0.63. What is the ratio of the Value added (current US$) of Low income in 2003 to that in 2006?
Keep it short and to the point. 0.68. What is the ratio of the Value added (current US$) in Colombia in 2003 to that in 2006?
Keep it short and to the point. 0.6. What is the ratio of the Value added (current US$) in Grenada in 2003 to that in 2006?
Your answer should be very brief. 0.86. What is the ratio of the Value added (current US$) of Sudan in 2003 to that in 2006?
Your answer should be very brief. 0.46. What is the ratio of the Value added (current US$) in Low income in 2004 to that in 2005?
Offer a terse response. 0.86. What is the ratio of the Value added (current US$) in Colombia in 2004 to that in 2005?
Keep it short and to the point. 0.8. What is the ratio of the Value added (current US$) of Grenada in 2004 to that in 2005?
Offer a very short reply. 0.93. What is the ratio of the Value added (current US$) in Sudan in 2004 to that in 2005?
Provide a short and direct response. 0.75. What is the ratio of the Value added (current US$) of Low income in 2004 to that in 2006?
Provide a short and direct response. 0.78. What is the ratio of the Value added (current US$) of Colombia in 2004 to that in 2006?
Your response must be concise. 0.74. What is the ratio of the Value added (current US$) of Grenada in 2004 to that in 2006?
Give a very brief answer. 0.89. What is the ratio of the Value added (current US$) in Sudan in 2004 to that in 2006?
Make the answer very short. 0.55. What is the ratio of the Value added (current US$) in Low income in 2005 to that in 2006?
Keep it short and to the point. 0.91. What is the ratio of the Value added (current US$) in Colombia in 2005 to that in 2006?
Give a very brief answer. 0.92. What is the ratio of the Value added (current US$) in Grenada in 2005 to that in 2006?
Make the answer very short. 0.96. What is the ratio of the Value added (current US$) of Sudan in 2005 to that in 2006?
Ensure brevity in your answer.  0.73. What is the difference between the highest and the second highest Value added (current US$) in Low income?
Your response must be concise. 6.43e+09. What is the difference between the highest and the second highest Value added (current US$) in Colombia?
Keep it short and to the point. 7.23e+09. What is the difference between the highest and the second highest Value added (current US$) of Grenada?
Ensure brevity in your answer.  1.71e+07. What is the difference between the highest and the second highest Value added (current US$) in Sudan?
Offer a terse response. 3.84e+09. What is the difference between the highest and the lowest Value added (current US$) in Low income?
Provide a succinct answer. 2.95e+1. What is the difference between the highest and the lowest Value added (current US$) of Colombia?
Your answer should be very brief. 3.41e+1. What is the difference between the highest and the lowest Value added (current US$) of Grenada?
Keep it short and to the point. 9.84e+07. What is the difference between the highest and the lowest Value added (current US$) in Sudan?
Ensure brevity in your answer.  9.47e+09. 